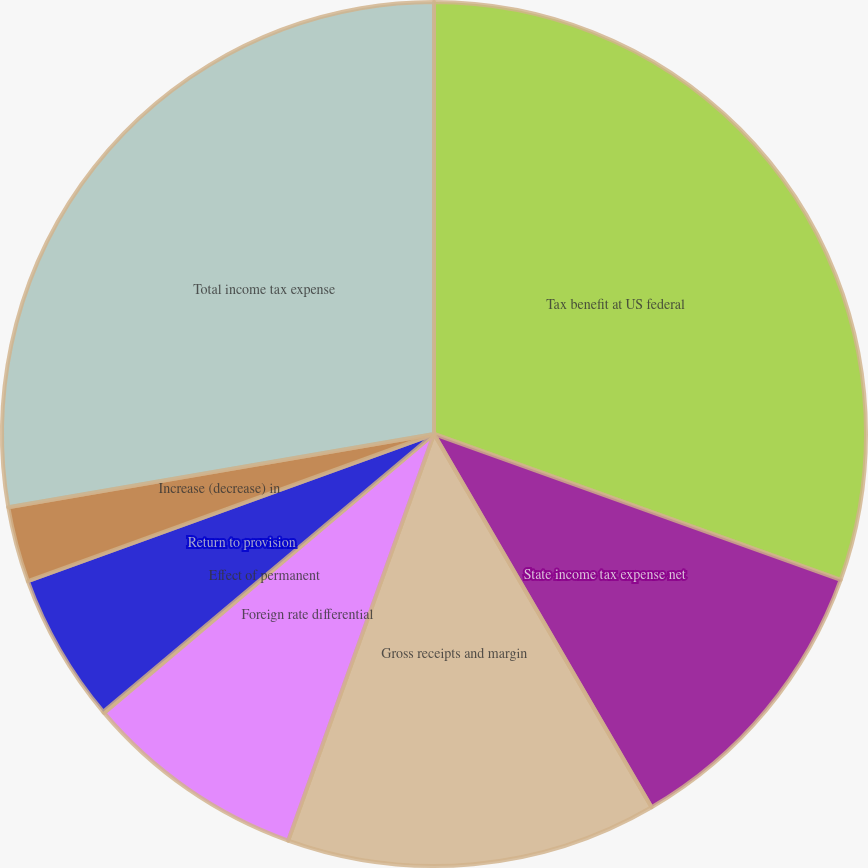Convert chart to OTSL. <chart><loc_0><loc_0><loc_500><loc_500><pie_chart><fcel>Tax benefit at US federal<fcel>State income tax expense net<fcel>Gross receipts and margin<fcel>Foreign rate differential<fcel>Effect of permanent<fcel>Return to provision<fcel>Increase (decrease) in<fcel>Total income tax expense<nl><fcel>30.48%<fcel>11.12%<fcel>13.88%<fcel>8.35%<fcel>0.05%<fcel>5.59%<fcel>2.82%<fcel>27.71%<nl></chart> 